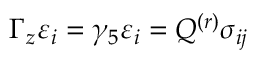<formula> <loc_0><loc_0><loc_500><loc_500>\Gamma _ { z } \varepsilon _ { i } = \gamma _ { 5 } \varepsilon _ { i } = Q ^ { ( r ) } \sigma _ { i j }</formula> 